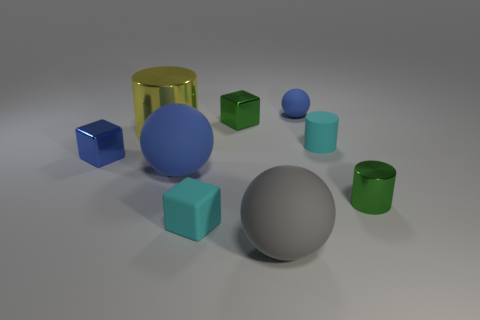Add 1 tiny red rubber things. How many objects exist? 10 Subtract all spheres. How many objects are left? 6 Add 5 gray matte things. How many gray matte things are left? 6 Add 6 yellow shiny cylinders. How many yellow shiny cylinders exist? 7 Subtract 0 blue cylinders. How many objects are left? 9 Subtract all large brown objects. Subtract all tiny blue metal things. How many objects are left? 8 